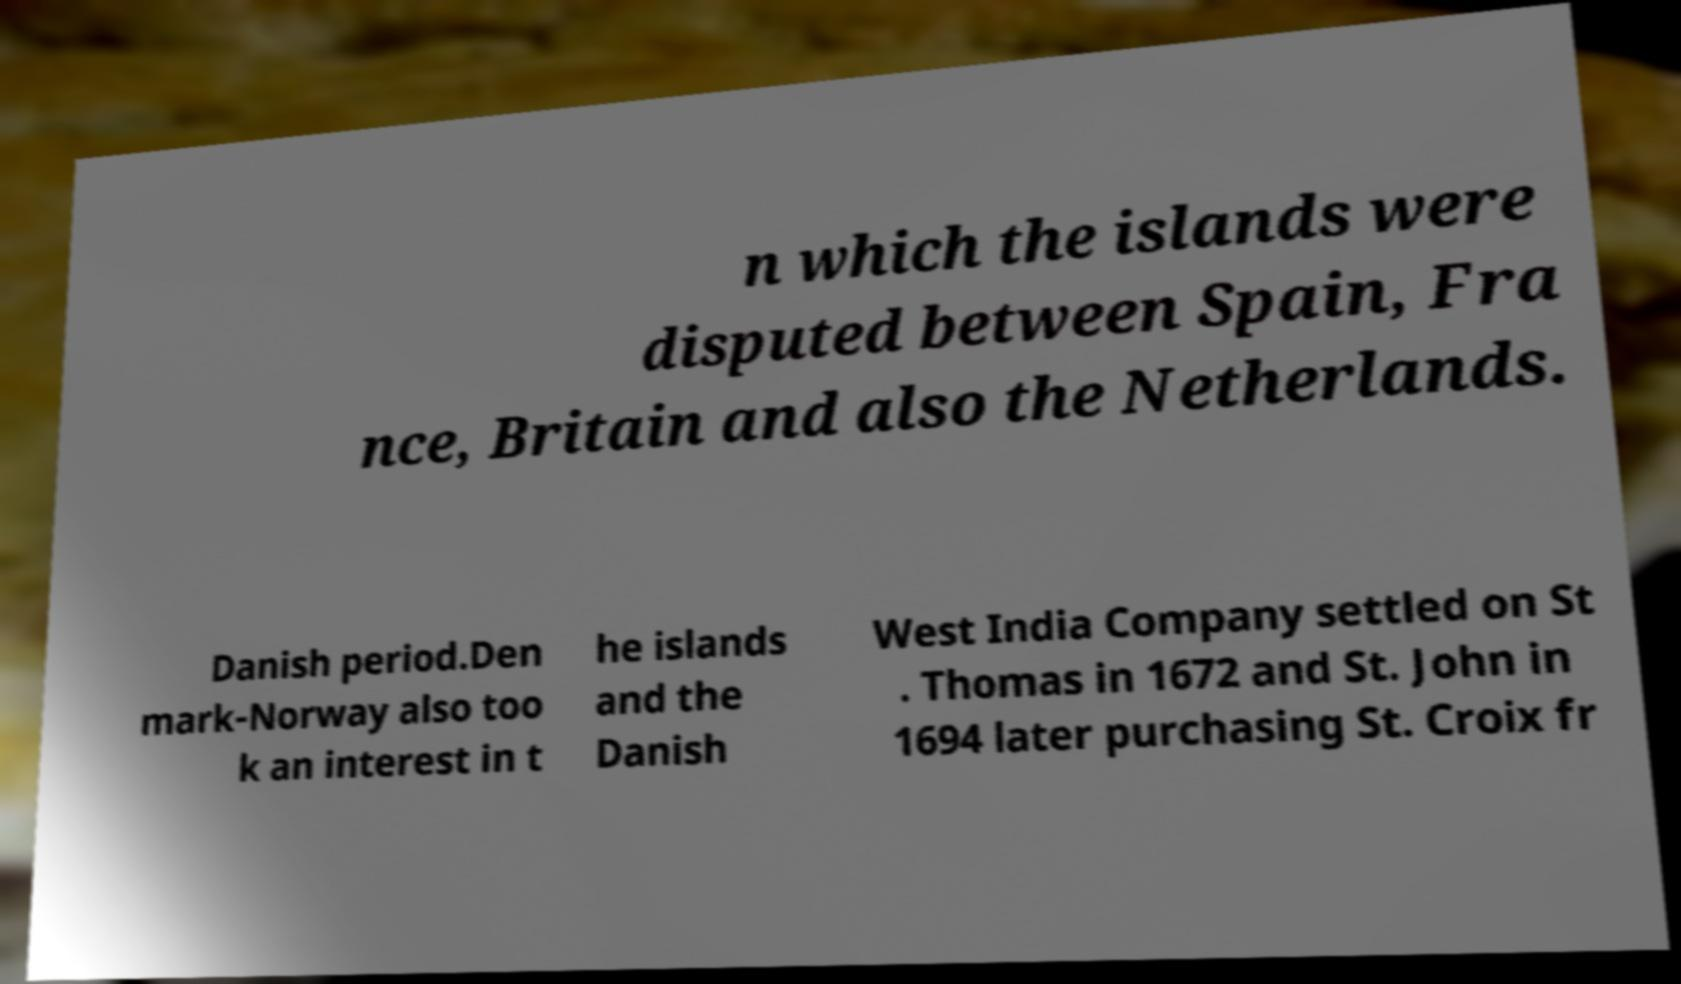I need the written content from this picture converted into text. Can you do that? n which the islands were disputed between Spain, Fra nce, Britain and also the Netherlands. Danish period.Den mark-Norway also too k an interest in t he islands and the Danish West India Company settled on St . Thomas in 1672 and St. John in 1694 later purchasing St. Croix fr 